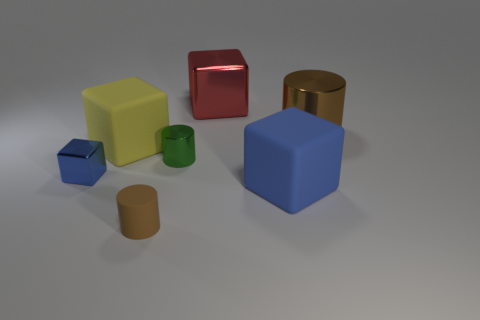The brown thing that is made of the same material as the yellow object is what shape?
Offer a very short reply. Cylinder. What is the color of the shiny cube that is the same size as the brown rubber thing?
Provide a succinct answer. Blue. There is a metal thing that is to the left of the yellow rubber object; is its size the same as the yellow matte thing?
Your response must be concise. No. Do the large shiny block and the big cylinder have the same color?
Make the answer very short. No. What number of small rubber blocks are there?
Your response must be concise. 0. How many blocks are either yellow matte things or blue matte things?
Offer a very short reply. 2. What number of big shiny cylinders are on the right side of the big metallic cylinder that is behind the yellow block?
Your response must be concise. 0. Does the green thing have the same material as the tiny block?
Offer a terse response. Yes. There is a rubber cylinder that is the same color as the big metal cylinder; what size is it?
Your response must be concise. Small. Is there a blue cube made of the same material as the small brown thing?
Keep it short and to the point. Yes. 